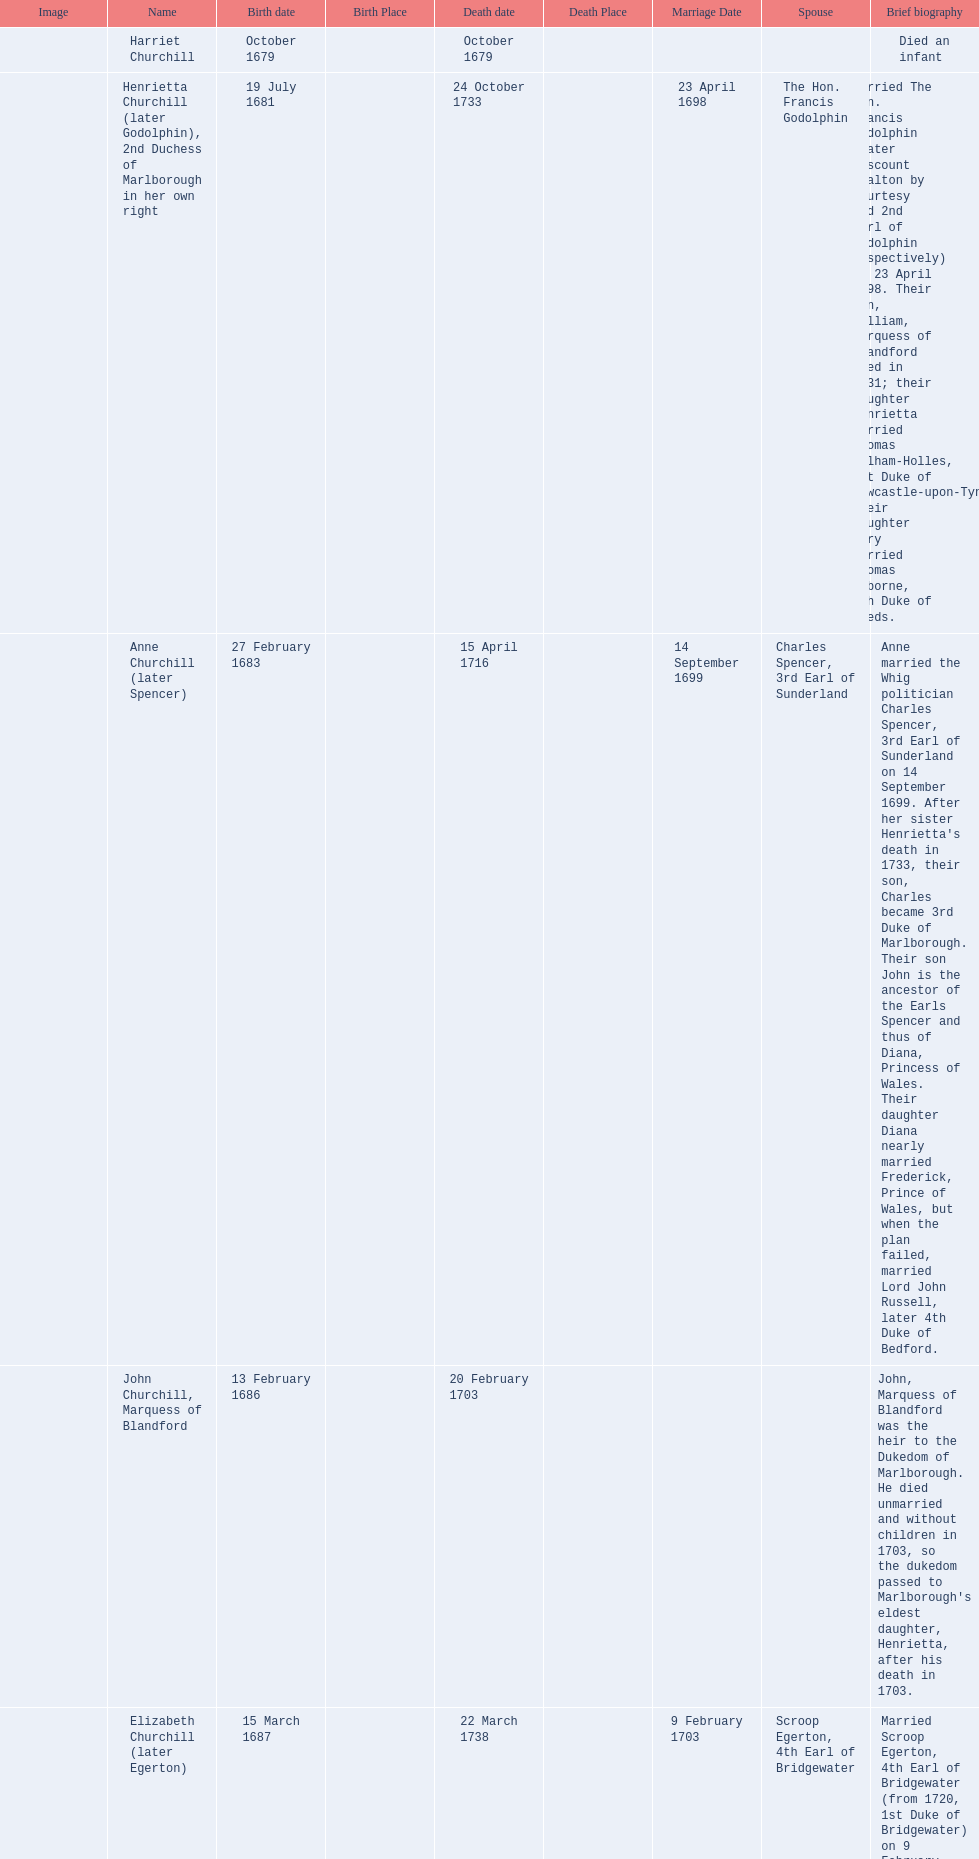How long did anne churchill/spencer live? 33. 